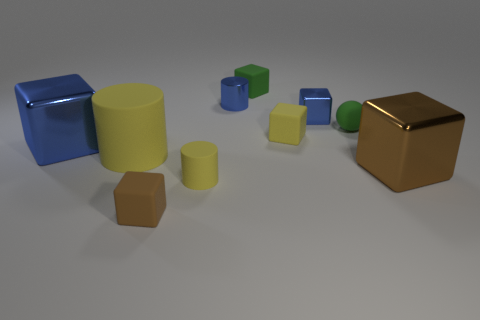Subtract all gray spheres. How many yellow cylinders are left? 2 Subtract all small blue cylinders. How many cylinders are left? 2 Subtract all yellow blocks. How many blocks are left? 5 Subtract 1 cylinders. How many cylinders are left? 2 Subtract all cylinders. How many objects are left? 7 Subtract all brown cubes. Subtract all yellow spheres. How many cubes are left? 4 Add 8 yellow cubes. How many yellow cubes exist? 9 Subtract 2 yellow cylinders. How many objects are left? 8 Subtract all tiny cyan metallic objects. Subtract all rubber balls. How many objects are left? 9 Add 2 tiny cubes. How many tiny cubes are left? 6 